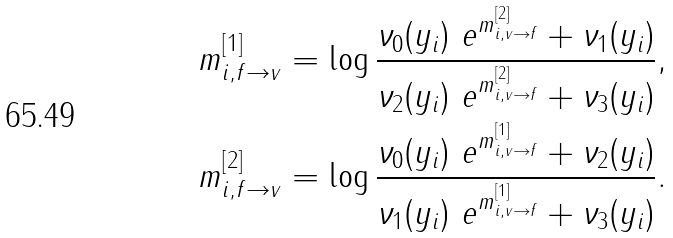Convert formula to latex. <formula><loc_0><loc_0><loc_500><loc_500>m ^ { [ 1 ] } _ { i , f \to v } & = \log \frac { \nu _ { 0 } ( y _ { i } ) \ e ^ { m ^ { [ 2 ] } _ { i , v \to f } } + \nu _ { 1 } ( y _ { i } ) } { \nu _ { 2 } ( y _ { i } ) \ e ^ { m ^ { [ 2 ] } _ { i , v \to f } } + \nu _ { 3 } ( y _ { i } ) } , \\ m ^ { [ 2 ] } _ { i , f \to v } & = \log \frac { \nu _ { 0 } ( y _ { i } ) \ e ^ { m ^ { [ 1 ] } _ { i , v \to f } } + \nu _ { 2 } ( y _ { i } ) } { \nu _ { 1 } ( y _ { i } ) \ e ^ { m ^ { [ 1 ] } _ { i , v \to f } } + \nu _ { 3 } ( y _ { i } ) } .</formula> 